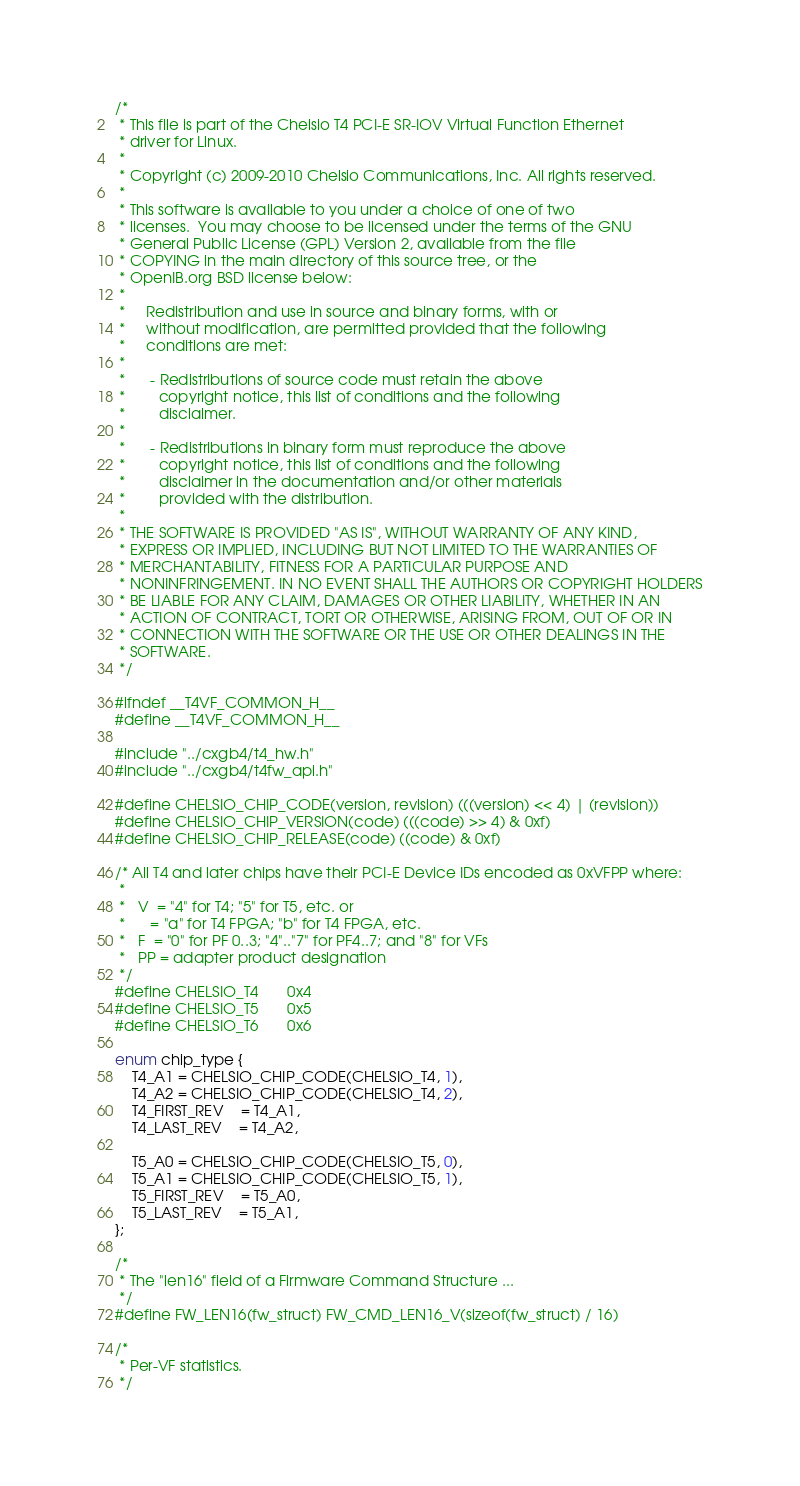Convert code to text. <code><loc_0><loc_0><loc_500><loc_500><_C_>/*
 * This file is part of the Chelsio T4 PCI-E SR-IOV Virtual Function Ethernet
 * driver for Linux.
 *
 * Copyright (c) 2009-2010 Chelsio Communications, Inc. All rights reserved.
 *
 * This software is available to you under a choice of one of two
 * licenses.  You may choose to be licensed under the terms of the GNU
 * General Public License (GPL) Version 2, available from the file
 * COPYING in the main directory of this source tree, or the
 * OpenIB.org BSD license below:
 *
 *     Redistribution and use in source and binary forms, with or
 *     without modification, are permitted provided that the following
 *     conditions are met:
 *
 *      - Redistributions of source code must retain the above
 *        copyright notice, this list of conditions and the following
 *        disclaimer.
 *
 *      - Redistributions in binary form must reproduce the above
 *        copyright notice, this list of conditions and the following
 *        disclaimer in the documentation and/or other materials
 *        provided with the distribution.
 *
 * THE SOFTWARE IS PROVIDED "AS IS", WITHOUT WARRANTY OF ANY KIND,
 * EXPRESS OR IMPLIED, INCLUDING BUT NOT LIMITED TO THE WARRANTIES OF
 * MERCHANTABILITY, FITNESS FOR A PARTICULAR PURPOSE AND
 * NONINFRINGEMENT. IN NO EVENT SHALL THE AUTHORS OR COPYRIGHT HOLDERS
 * BE LIABLE FOR ANY CLAIM, DAMAGES OR OTHER LIABILITY, WHETHER IN AN
 * ACTION OF CONTRACT, TORT OR OTHERWISE, ARISING FROM, OUT OF OR IN
 * CONNECTION WITH THE SOFTWARE OR THE USE OR OTHER DEALINGS IN THE
 * SOFTWARE.
 */

#ifndef __T4VF_COMMON_H__
#define __T4VF_COMMON_H__

#include "../cxgb4/t4_hw.h"
#include "../cxgb4/t4fw_api.h"

#define CHELSIO_CHIP_CODE(version, revision) (((version) << 4) | (revision))
#define CHELSIO_CHIP_VERSION(code) (((code) >> 4) & 0xf)
#define CHELSIO_CHIP_RELEASE(code) ((code) & 0xf)

/* All T4 and later chips have their PCI-E Device IDs encoded as 0xVFPP where:
 *
 *   V  = "4" for T4; "5" for T5, etc. or
 *      = "a" for T4 FPGA; "b" for T4 FPGA, etc.
 *   F  = "0" for PF 0..3; "4".."7" for PF4..7; and "8" for VFs
 *   PP = adapter product designation
 */
#define CHELSIO_T4		0x4
#define CHELSIO_T5		0x5
#define CHELSIO_T6		0x6

enum chip_type {
	T4_A1 = CHELSIO_CHIP_CODE(CHELSIO_T4, 1),
	T4_A2 = CHELSIO_CHIP_CODE(CHELSIO_T4, 2),
	T4_FIRST_REV	= T4_A1,
	T4_LAST_REV	= T4_A2,

	T5_A0 = CHELSIO_CHIP_CODE(CHELSIO_T5, 0),
	T5_A1 = CHELSIO_CHIP_CODE(CHELSIO_T5, 1),
	T5_FIRST_REV	= T5_A0,
	T5_LAST_REV	= T5_A1,
};

/*
 * The "len16" field of a Firmware Command Structure ...
 */
#define FW_LEN16(fw_struct) FW_CMD_LEN16_V(sizeof(fw_struct) / 16)

/*
 * Per-VF statistics.
 */</code> 